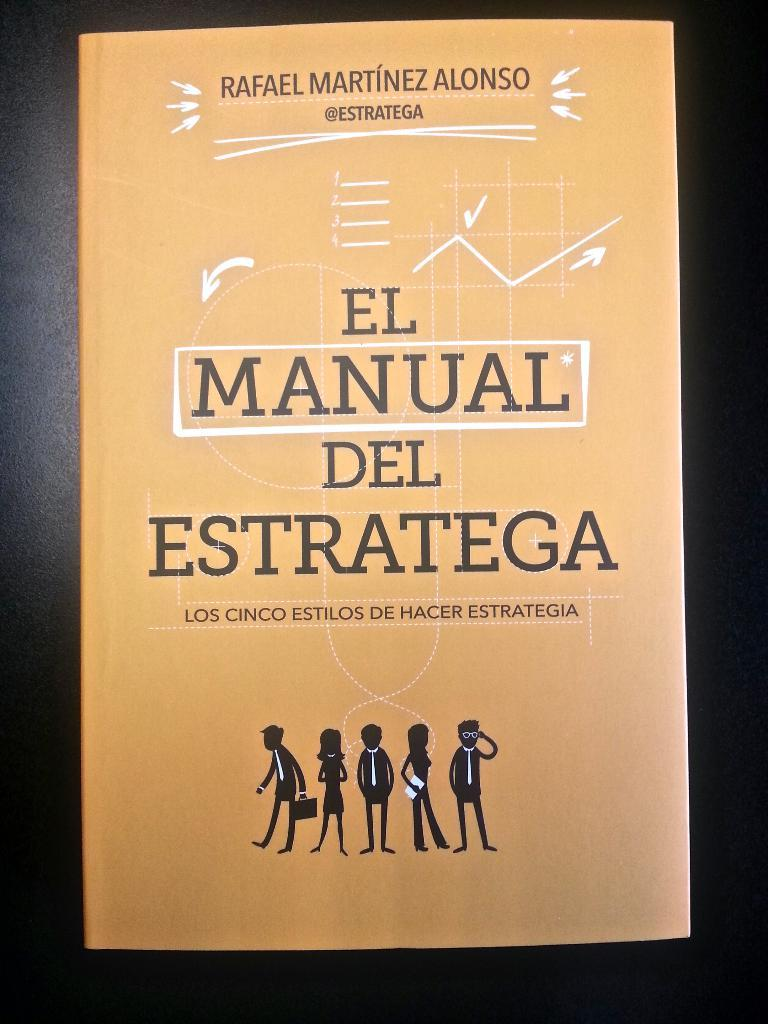Provide a one-sentence caption for the provided image. El Manual Del Estratega was written by Rafael Martinez Alonso. 